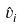<formula> <loc_0><loc_0><loc_500><loc_500>\hat { v } _ { i }</formula> 